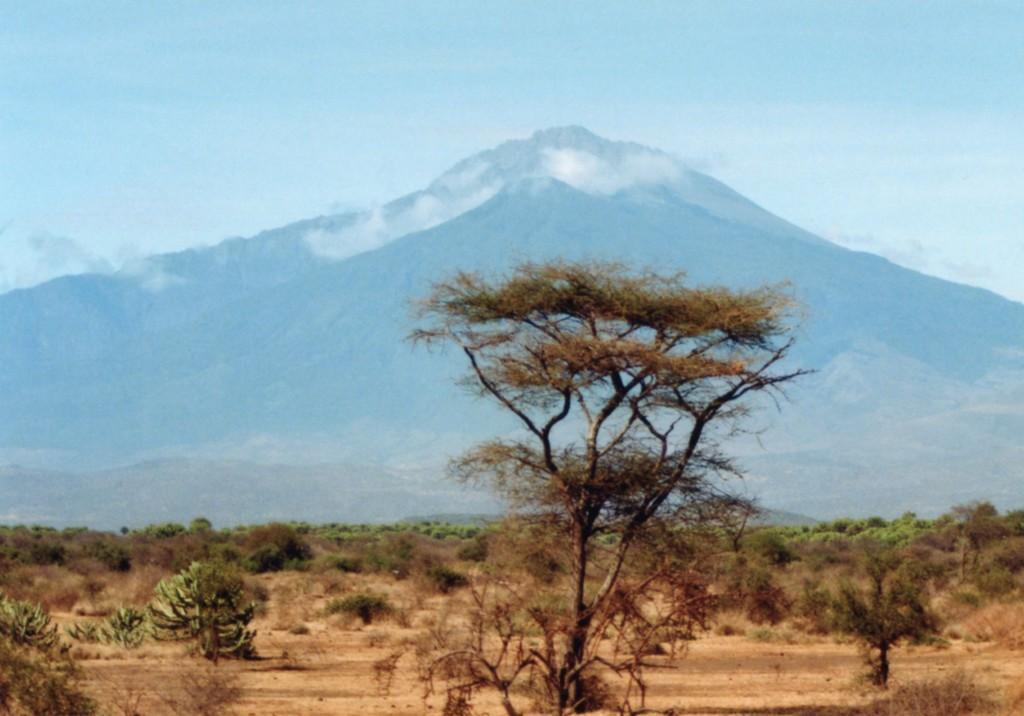In one or two sentences, can you explain what this image depicts? In this image I can see many trees. In the background I can see the mountains and the sky. 